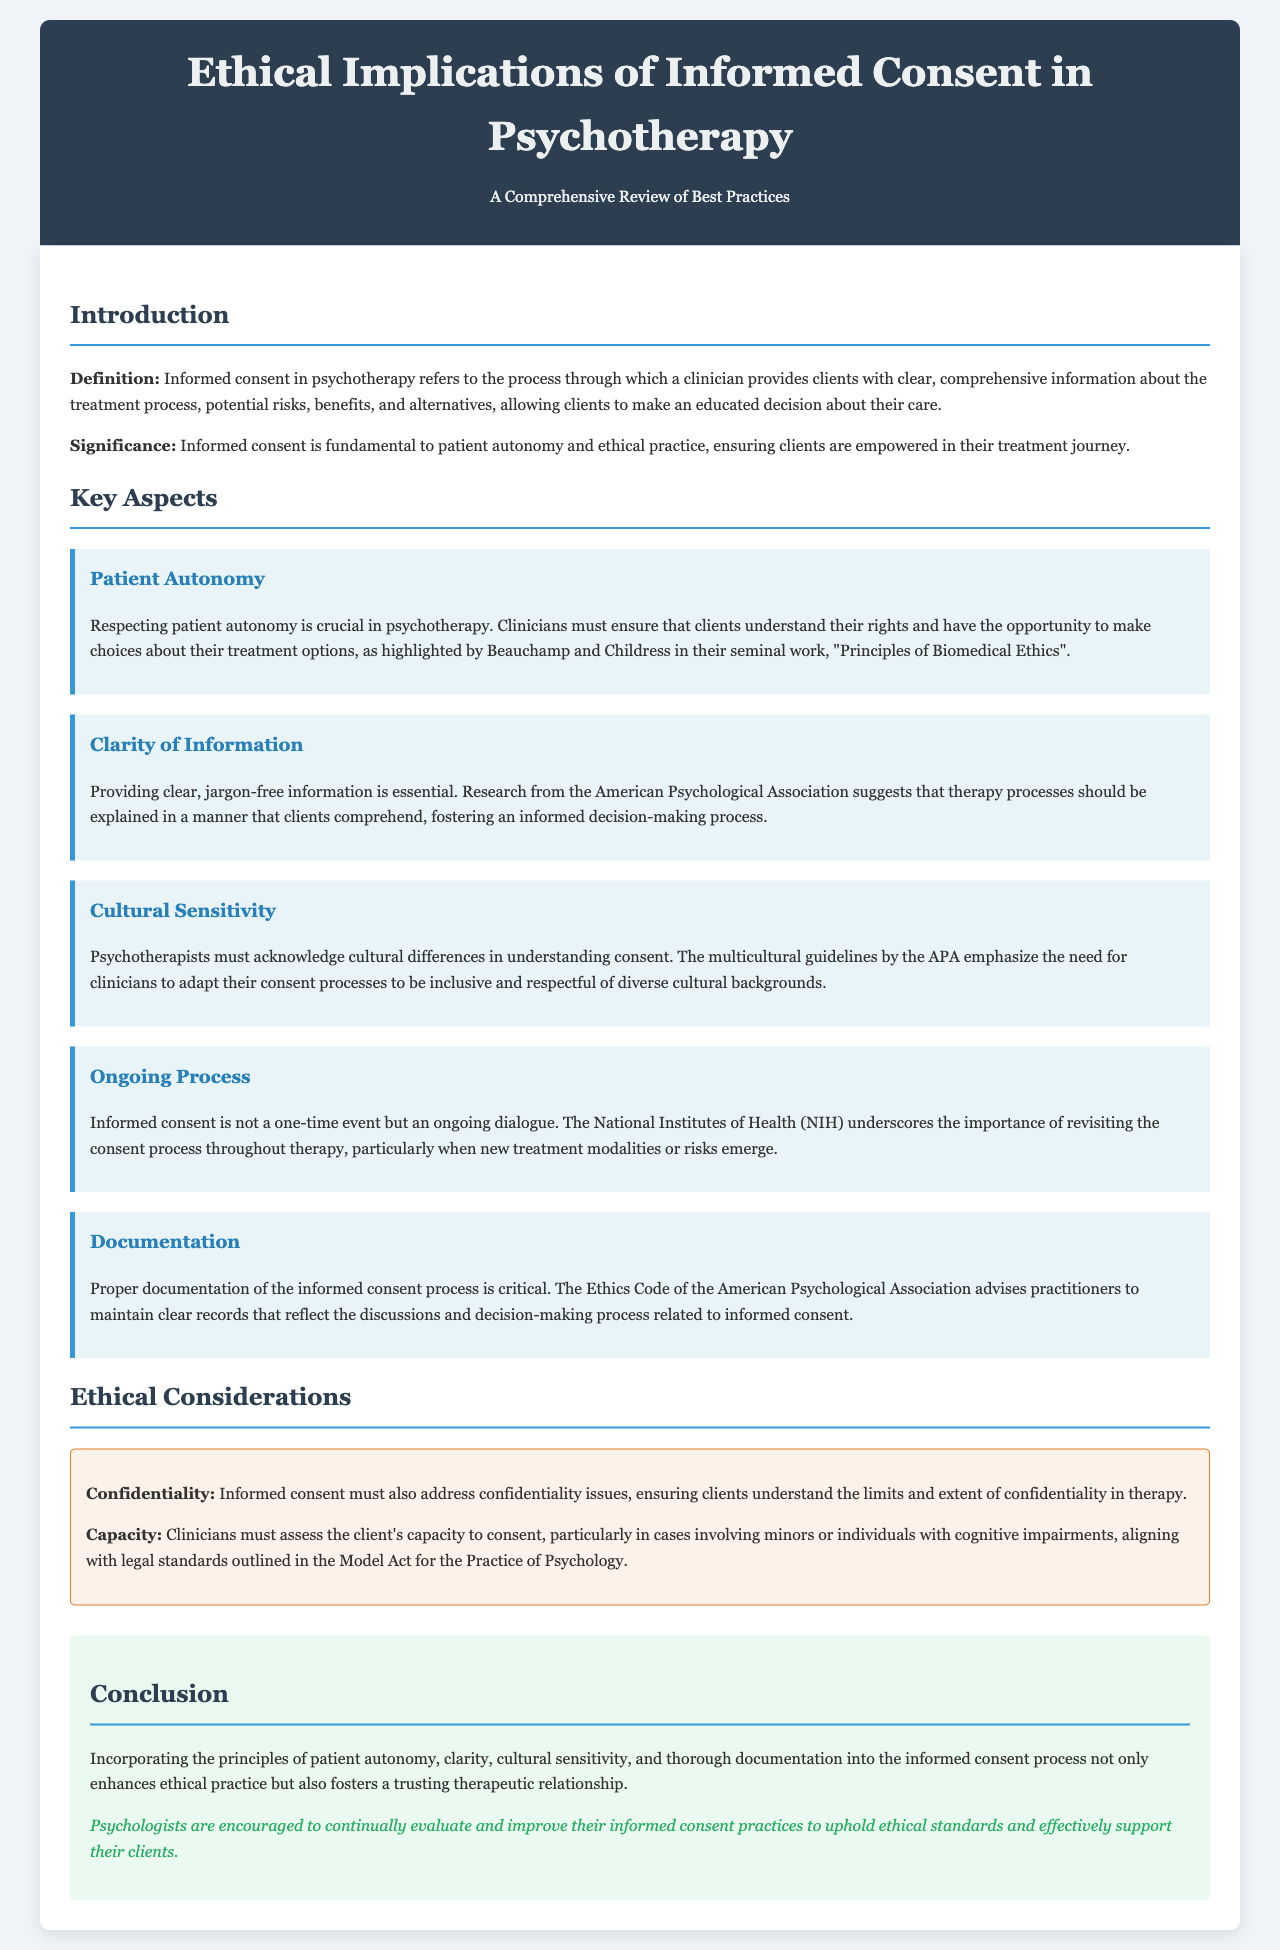What is the primary focus of the report? The report primarily focuses on the ethical implications of informed consent in psychotherapy and best practices.
Answer: Ethical implications of informed consent in psychotherapy Who are the authors referenced for patient autonomy? The report references Beauchamp and Childress regarding the importance of patient autonomy in psychotherapy.
Answer: Beauchamp and Childress What is the essential principle highlighted in the introduction regarding informed consent? The introduction stresses that informed consent is crucial for patient autonomy and ethical practice in psychotherapy.
Answer: Patient autonomy How is the consent process characterized in terms of duration? The report indicates that informed consent is an ongoing dialogue, not a one-time event.
Answer: Ongoing dialogue Which organization emphasizes cultural sensitivity in psychotherapy? The American Psychological Association is noted for emphasizing the need for cultural sensitivity in the consent process.
Answer: American Psychological Association What is one of the critical ethical considerations mentioned in the document? A key ethical consideration mentioned is confidentiality regarding the limits of confidentiality in therapy.
Answer: Confidentiality What should clinicians assess regarding clients before informed consent? Clinicians must assess the client's capacity to consent, especially in cases involving minors or cognitive impairments.
Answer: Client's capacity What is the recommended practice regarding documentation of informed consent? The report advises that practitioners maintain clear records of the informed consent discussions and decision-making process.
Answer: Clear records What does the call to action encourage psychologists to do? The call to action encourages psychologists to continually evaluate and improve their informed consent practices.
Answer: Evaluate and improve informed consent practices 